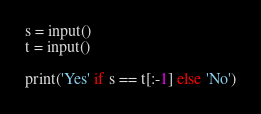Convert code to text. <code><loc_0><loc_0><loc_500><loc_500><_Python_>s = input()
t = input()

print('Yes' if s == t[:-1] else 'No')</code> 